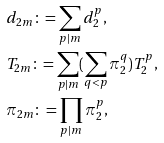<formula> <loc_0><loc_0><loc_500><loc_500>& d _ { 2 m } \colon = \sum _ { p | m } d _ { 2 } ^ { p } , \\ & T _ { 2 m } \colon = \sum _ { p | m } ( \sum _ { q < p } \pi _ { 2 } ^ { q } ) T _ { 2 } ^ { p } , \\ & \pi _ { 2 m } \colon = \prod _ { p | m } \pi _ { 2 } ^ { p } ,</formula> 